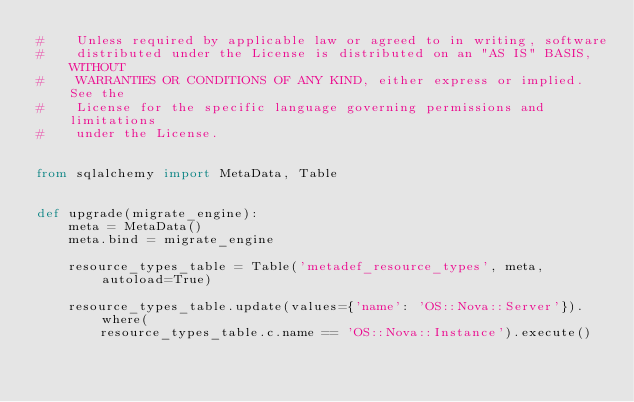Convert code to text. <code><loc_0><loc_0><loc_500><loc_500><_Python_>#    Unless required by applicable law or agreed to in writing, software
#    distributed under the License is distributed on an "AS IS" BASIS, WITHOUT
#    WARRANTIES OR CONDITIONS OF ANY KIND, either express or implied. See the
#    License for the specific language governing permissions and limitations
#    under the License.


from sqlalchemy import MetaData, Table


def upgrade(migrate_engine):
    meta = MetaData()
    meta.bind = migrate_engine

    resource_types_table = Table('metadef_resource_types', meta, autoload=True)

    resource_types_table.update(values={'name': 'OS::Nova::Server'}).where(
        resource_types_table.c.name == 'OS::Nova::Instance').execute()
</code> 